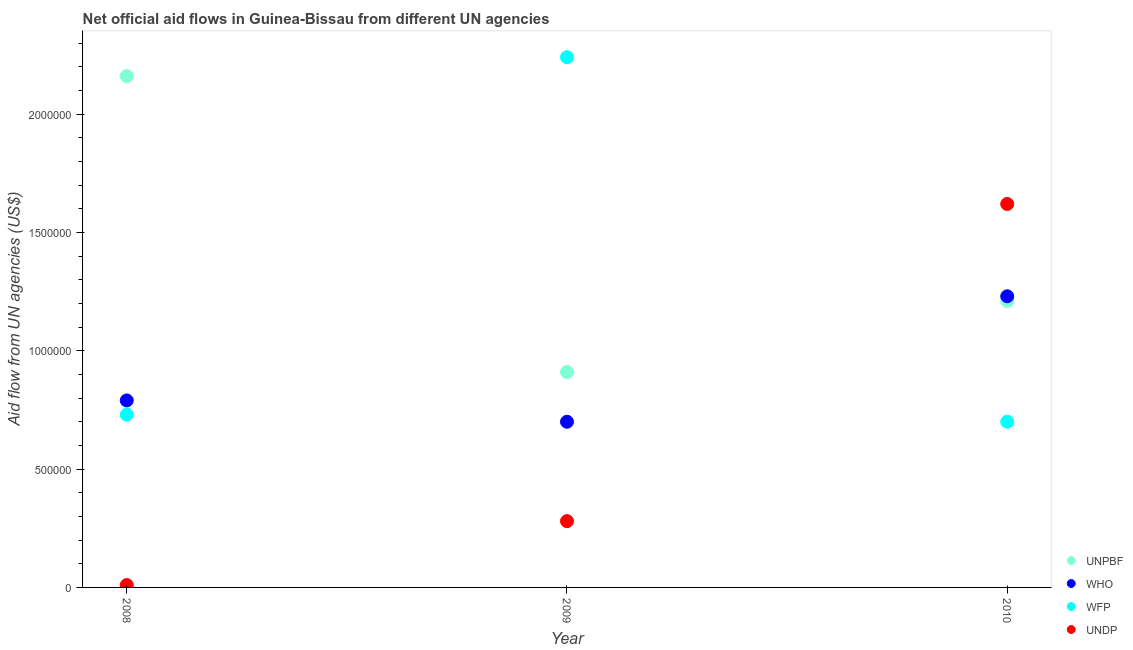What is the amount of aid given by undp in 2008?
Your response must be concise. 10000. Across all years, what is the maximum amount of aid given by undp?
Offer a terse response. 1.62e+06. Across all years, what is the minimum amount of aid given by wfp?
Offer a very short reply. 7.00e+05. In which year was the amount of aid given by undp maximum?
Provide a succinct answer. 2010. In which year was the amount of aid given by who minimum?
Give a very brief answer. 2009. What is the total amount of aid given by who in the graph?
Your answer should be compact. 2.72e+06. What is the difference between the amount of aid given by who in 2008 and that in 2009?
Your response must be concise. 9.00e+04. What is the difference between the amount of aid given by unpbf in 2009 and the amount of aid given by who in 2008?
Keep it short and to the point. 1.20e+05. What is the average amount of aid given by who per year?
Your response must be concise. 9.07e+05. In the year 2009, what is the difference between the amount of aid given by who and amount of aid given by undp?
Provide a short and direct response. 4.20e+05. In how many years, is the amount of aid given by wfp greater than 200000 US$?
Keep it short and to the point. 3. What is the ratio of the amount of aid given by who in 2008 to that in 2009?
Offer a terse response. 1.13. Is the difference between the amount of aid given by who in 2008 and 2010 greater than the difference between the amount of aid given by undp in 2008 and 2010?
Make the answer very short. Yes. What is the difference between the highest and the second highest amount of aid given by unpbf?
Provide a short and direct response. 9.50e+05. What is the difference between the highest and the lowest amount of aid given by wfp?
Your answer should be very brief. 1.54e+06. Is the amount of aid given by who strictly greater than the amount of aid given by undp over the years?
Your response must be concise. No. Is the amount of aid given by wfp strictly less than the amount of aid given by undp over the years?
Your response must be concise. No. What is the difference between two consecutive major ticks on the Y-axis?
Ensure brevity in your answer.  5.00e+05. Are the values on the major ticks of Y-axis written in scientific E-notation?
Provide a short and direct response. No. What is the title of the graph?
Make the answer very short. Net official aid flows in Guinea-Bissau from different UN agencies. What is the label or title of the X-axis?
Keep it short and to the point. Year. What is the label or title of the Y-axis?
Offer a terse response. Aid flow from UN agencies (US$). What is the Aid flow from UN agencies (US$) in UNPBF in 2008?
Your answer should be compact. 2.16e+06. What is the Aid flow from UN agencies (US$) of WHO in 2008?
Provide a short and direct response. 7.90e+05. What is the Aid flow from UN agencies (US$) in WFP in 2008?
Give a very brief answer. 7.30e+05. What is the Aid flow from UN agencies (US$) of UNDP in 2008?
Provide a succinct answer. 10000. What is the Aid flow from UN agencies (US$) of UNPBF in 2009?
Make the answer very short. 9.10e+05. What is the Aid flow from UN agencies (US$) of WFP in 2009?
Keep it short and to the point. 2.24e+06. What is the Aid flow from UN agencies (US$) in UNPBF in 2010?
Offer a very short reply. 1.21e+06. What is the Aid flow from UN agencies (US$) in WHO in 2010?
Keep it short and to the point. 1.23e+06. What is the Aid flow from UN agencies (US$) of WFP in 2010?
Your response must be concise. 7.00e+05. What is the Aid flow from UN agencies (US$) of UNDP in 2010?
Make the answer very short. 1.62e+06. Across all years, what is the maximum Aid flow from UN agencies (US$) in UNPBF?
Ensure brevity in your answer.  2.16e+06. Across all years, what is the maximum Aid flow from UN agencies (US$) of WHO?
Provide a short and direct response. 1.23e+06. Across all years, what is the maximum Aid flow from UN agencies (US$) in WFP?
Your answer should be compact. 2.24e+06. Across all years, what is the maximum Aid flow from UN agencies (US$) in UNDP?
Provide a succinct answer. 1.62e+06. Across all years, what is the minimum Aid flow from UN agencies (US$) in UNPBF?
Give a very brief answer. 9.10e+05. Across all years, what is the minimum Aid flow from UN agencies (US$) of WFP?
Your response must be concise. 7.00e+05. Across all years, what is the minimum Aid flow from UN agencies (US$) in UNDP?
Offer a very short reply. 10000. What is the total Aid flow from UN agencies (US$) of UNPBF in the graph?
Make the answer very short. 4.28e+06. What is the total Aid flow from UN agencies (US$) of WHO in the graph?
Provide a succinct answer. 2.72e+06. What is the total Aid flow from UN agencies (US$) in WFP in the graph?
Ensure brevity in your answer.  3.67e+06. What is the total Aid flow from UN agencies (US$) of UNDP in the graph?
Your response must be concise. 1.91e+06. What is the difference between the Aid flow from UN agencies (US$) of UNPBF in 2008 and that in 2009?
Ensure brevity in your answer.  1.25e+06. What is the difference between the Aid flow from UN agencies (US$) of WHO in 2008 and that in 2009?
Offer a very short reply. 9.00e+04. What is the difference between the Aid flow from UN agencies (US$) of WFP in 2008 and that in 2009?
Provide a succinct answer. -1.51e+06. What is the difference between the Aid flow from UN agencies (US$) in UNPBF in 2008 and that in 2010?
Keep it short and to the point. 9.50e+05. What is the difference between the Aid flow from UN agencies (US$) of WHO in 2008 and that in 2010?
Your answer should be very brief. -4.40e+05. What is the difference between the Aid flow from UN agencies (US$) in WFP in 2008 and that in 2010?
Provide a short and direct response. 3.00e+04. What is the difference between the Aid flow from UN agencies (US$) in UNDP in 2008 and that in 2010?
Provide a succinct answer. -1.61e+06. What is the difference between the Aid flow from UN agencies (US$) of UNPBF in 2009 and that in 2010?
Provide a short and direct response. -3.00e+05. What is the difference between the Aid flow from UN agencies (US$) in WHO in 2009 and that in 2010?
Provide a short and direct response. -5.30e+05. What is the difference between the Aid flow from UN agencies (US$) in WFP in 2009 and that in 2010?
Offer a very short reply. 1.54e+06. What is the difference between the Aid flow from UN agencies (US$) of UNDP in 2009 and that in 2010?
Your response must be concise. -1.34e+06. What is the difference between the Aid flow from UN agencies (US$) of UNPBF in 2008 and the Aid flow from UN agencies (US$) of WHO in 2009?
Provide a short and direct response. 1.46e+06. What is the difference between the Aid flow from UN agencies (US$) of UNPBF in 2008 and the Aid flow from UN agencies (US$) of WFP in 2009?
Make the answer very short. -8.00e+04. What is the difference between the Aid flow from UN agencies (US$) of UNPBF in 2008 and the Aid flow from UN agencies (US$) of UNDP in 2009?
Provide a succinct answer. 1.88e+06. What is the difference between the Aid flow from UN agencies (US$) in WHO in 2008 and the Aid flow from UN agencies (US$) in WFP in 2009?
Offer a very short reply. -1.45e+06. What is the difference between the Aid flow from UN agencies (US$) of WHO in 2008 and the Aid flow from UN agencies (US$) of UNDP in 2009?
Offer a very short reply. 5.10e+05. What is the difference between the Aid flow from UN agencies (US$) of WFP in 2008 and the Aid flow from UN agencies (US$) of UNDP in 2009?
Provide a succinct answer. 4.50e+05. What is the difference between the Aid flow from UN agencies (US$) in UNPBF in 2008 and the Aid flow from UN agencies (US$) in WHO in 2010?
Offer a very short reply. 9.30e+05. What is the difference between the Aid flow from UN agencies (US$) in UNPBF in 2008 and the Aid flow from UN agencies (US$) in WFP in 2010?
Your response must be concise. 1.46e+06. What is the difference between the Aid flow from UN agencies (US$) in UNPBF in 2008 and the Aid flow from UN agencies (US$) in UNDP in 2010?
Make the answer very short. 5.40e+05. What is the difference between the Aid flow from UN agencies (US$) of WHO in 2008 and the Aid flow from UN agencies (US$) of UNDP in 2010?
Offer a terse response. -8.30e+05. What is the difference between the Aid flow from UN agencies (US$) of WFP in 2008 and the Aid flow from UN agencies (US$) of UNDP in 2010?
Make the answer very short. -8.90e+05. What is the difference between the Aid flow from UN agencies (US$) in UNPBF in 2009 and the Aid flow from UN agencies (US$) in WHO in 2010?
Offer a terse response. -3.20e+05. What is the difference between the Aid flow from UN agencies (US$) in UNPBF in 2009 and the Aid flow from UN agencies (US$) in WFP in 2010?
Provide a succinct answer. 2.10e+05. What is the difference between the Aid flow from UN agencies (US$) in UNPBF in 2009 and the Aid flow from UN agencies (US$) in UNDP in 2010?
Keep it short and to the point. -7.10e+05. What is the difference between the Aid flow from UN agencies (US$) in WHO in 2009 and the Aid flow from UN agencies (US$) in WFP in 2010?
Your answer should be very brief. 0. What is the difference between the Aid flow from UN agencies (US$) of WHO in 2009 and the Aid flow from UN agencies (US$) of UNDP in 2010?
Your answer should be compact. -9.20e+05. What is the difference between the Aid flow from UN agencies (US$) of WFP in 2009 and the Aid flow from UN agencies (US$) of UNDP in 2010?
Provide a short and direct response. 6.20e+05. What is the average Aid flow from UN agencies (US$) in UNPBF per year?
Your answer should be very brief. 1.43e+06. What is the average Aid flow from UN agencies (US$) of WHO per year?
Ensure brevity in your answer.  9.07e+05. What is the average Aid flow from UN agencies (US$) of WFP per year?
Provide a succinct answer. 1.22e+06. What is the average Aid flow from UN agencies (US$) of UNDP per year?
Provide a succinct answer. 6.37e+05. In the year 2008, what is the difference between the Aid flow from UN agencies (US$) in UNPBF and Aid flow from UN agencies (US$) in WHO?
Offer a very short reply. 1.37e+06. In the year 2008, what is the difference between the Aid flow from UN agencies (US$) in UNPBF and Aid flow from UN agencies (US$) in WFP?
Provide a short and direct response. 1.43e+06. In the year 2008, what is the difference between the Aid flow from UN agencies (US$) of UNPBF and Aid flow from UN agencies (US$) of UNDP?
Your response must be concise. 2.15e+06. In the year 2008, what is the difference between the Aid flow from UN agencies (US$) in WHO and Aid flow from UN agencies (US$) in UNDP?
Ensure brevity in your answer.  7.80e+05. In the year 2008, what is the difference between the Aid flow from UN agencies (US$) in WFP and Aid flow from UN agencies (US$) in UNDP?
Make the answer very short. 7.20e+05. In the year 2009, what is the difference between the Aid flow from UN agencies (US$) in UNPBF and Aid flow from UN agencies (US$) in WFP?
Offer a very short reply. -1.33e+06. In the year 2009, what is the difference between the Aid flow from UN agencies (US$) of UNPBF and Aid flow from UN agencies (US$) of UNDP?
Offer a terse response. 6.30e+05. In the year 2009, what is the difference between the Aid flow from UN agencies (US$) in WHO and Aid flow from UN agencies (US$) in WFP?
Keep it short and to the point. -1.54e+06. In the year 2009, what is the difference between the Aid flow from UN agencies (US$) in WHO and Aid flow from UN agencies (US$) in UNDP?
Your response must be concise. 4.20e+05. In the year 2009, what is the difference between the Aid flow from UN agencies (US$) of WFP and Aid flow from UN agencies (US$) of UNDP?
Ensure brevity in your answer.  1.96e+06. In the year 2010, what is the difference between the Aid flow from UN agencies (US$) in UNPBF and Aid flow from UN agencies (US$) in WFP?
Provide a short and direct response. 5.10e+05. In the year 2010, what is the difference between the Aid flow from UN agencies (US$) of UNPBF and Aid flow from UN agencies (US$) of UNDP?
Offer a terse response. -4.10e+05. In the year 2010, what is the difference between the Aid flow from UN agencies (US$) in WHO and Aid flow from UN agencies (US$) in WFP?
Provide a succinct answer. 5.30e+05. In the year 2010, what is the difference between the Aid flow from UN agencies (US$) of WHO and Aid flow from UN agencies (US$) of UNDP?
Your answer should be very brief. -3.90e+05. In the year 2010, what is the difference between the Aid flow from UN agencies (US$) in WFP and Aid flow from UN agencies (US$) in UNDP?
Provide a short and direct response. -9.20e+05. What is the ratio of the Aid flow from UN agencies (US$) in UNPBF in 2008 to that in 2009?
Provide a short and direct response. 2.37. What is the ratio of the Aid flow from UN agencies (US$) of WHO in 2008 to that in 2009?
Make the answer very short. 1.13. What is the ratio of the Aid flow from UN agencies (US$) in WFP in 2008 to that in 2009?
Ensure brevity in your answer.  0.33. What is the ratio of the Aid flow from UN agencies (US$) in UNDP in 2008 to that in 2009?
Ensure brevity in your answer.  0.04. What is the ratio of the Aid flow from UN agencies (US$) in UNPBF in 2008 to that in 2010?
Your response must be concise. 1.79. What is the ratio of the Aid flow from UN agencies (US$) in WHO in 2008 to that in 2010?
Your answer should be compact. 0.64. What is the ratio of the Aid flow from UN agencies (US$) in WFP in 2008 to that in 2010?
Keep it short and to the point. 1.04. What is the ratio of the Aid flow from UN agencies (US$) of UNDP in 2008 to that in 2010?
Provide a succinct answer. 0.01. What is the ratio of the Aid flow from UN agencies (US$) in UNPBF in 2009 to that in 2010?
Provide a succinct answer. 0.75. What is the ratio of the Aid flow from UN agencies (US$) of WHO in 2009 to that in 2010?
Your response must be concise. 0.57. What is the ratio of the Aid flow from UN agencies (US$) of UNDP in 2009 to that in 2010?
Give a very brief answer. 0.17. What is the difference between the highest and the second highest Aid flow from UN agencies (US$) in UNPBF?
Offer a terse response. 9.50e+05. What is the difference between the highest and the second highest Aid flow from UN agencies (US$) in WHO?
Your response must be concise. 4.40e+05. What is the difference between the highest and the second highest Aid flow from UN agencies (US$) in WFP?
Your answer should be compact. 1.51e+06. What is the difference between the highest and the second highest Aid flow from UN agencies (US$) in UNDP?
Ensure brevity in your answer.  1.34e+06. What is the difference between the highest and the lowest Aid flow from UN agencies (US$) in UNPBF?
Provide a short and direct response. 1.25e+06. What is the difference between the highest and the lowest Aid flow from UN agencies (US$) of WHO?
Keep it short and to the point. 5.30e+05. What is the difference between the highest and the lowest Aid flow from UN agencies (US$) of WFP?
Your answer should be very brief. 1.54e+06. What is the difference between the highest and the lowest Aid flow from UN agencies (US$) in UNDP?
Your answer should be compact. 1.61e+06. 